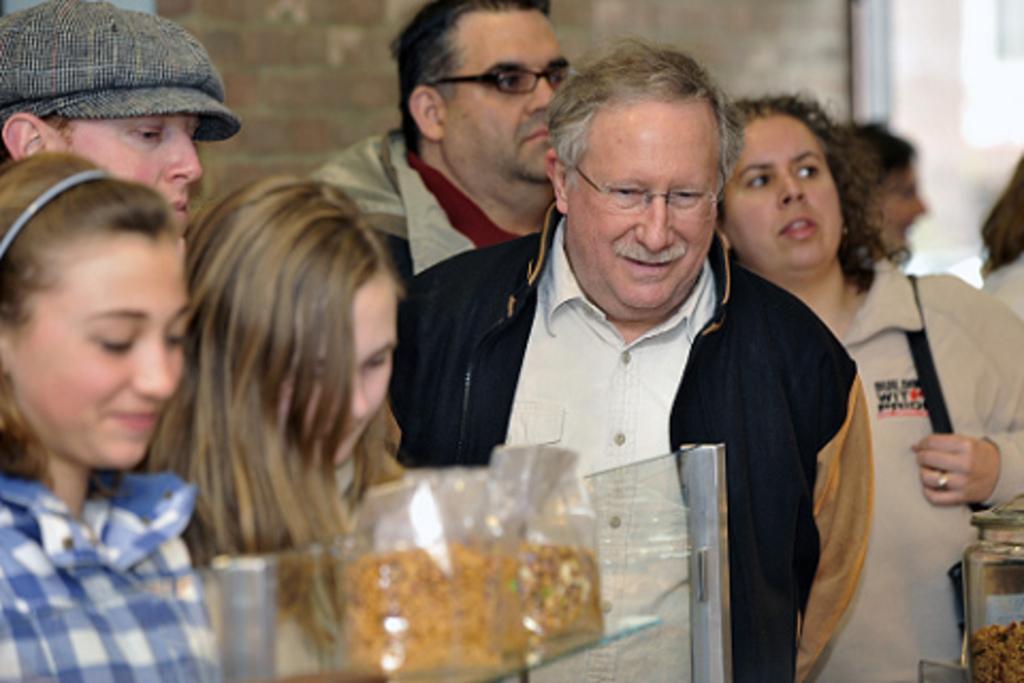Could you give a brief overview of what you see in this image? In this image we can see persons standing. In the background we can see pet jars and wall. 